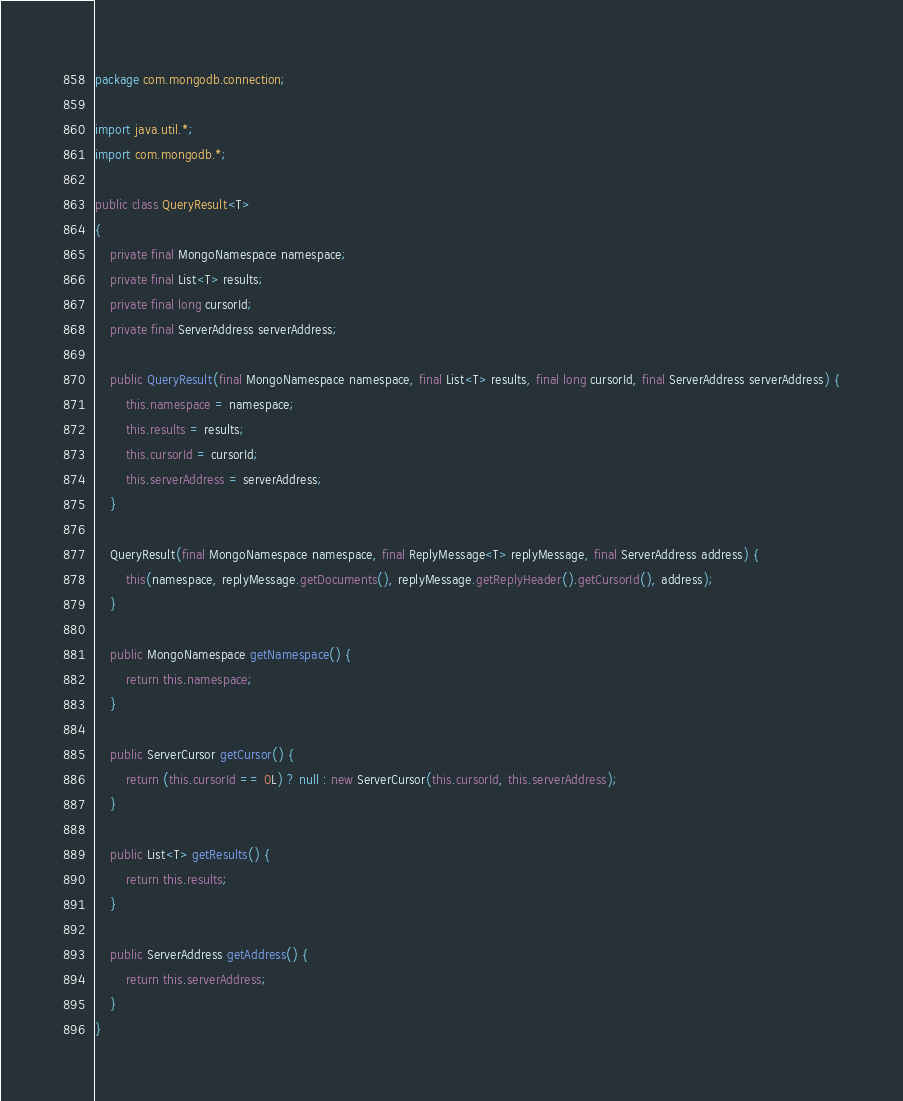Convert code to text. <code><loc_0><loc_0><loc_500><loc_500><_Java_>package com.mongodb.connection;

import java.util.*;
import com.mongodb.*;

public class QueryResult<T>
{
    private final MongoNamespace namespace;
    private final List<T> results;
    private final long cursorId;
    private final ServerAddress serverAddress;
    
    public QueryResult(final MongoNamespace namespace, final List<T> results, final long cursorId, final ServerAddress serverAddress) {
        this.namespace = namespace;
        this.results = results;
        this.cursorId = cursorId;
        this.serverAddress = serverAddress;
    }
    
    QueryResult(final MongoNamespace namespace, final ReplyMessage<T> replyMessage, final ServerAddress address) {
        this(namespace, replyMessage.getDocuments(), replyMessage.getReplyHeader().getCursorId(), address);
    }
    
    public MongoNamespace getNamespace() {
        return this.namespace;
    }
    
    public ServerCursor getCursor() {
        return (this.cursorId == 0L) ? null : new ServerCursor(this.cursorId, this.serverAddress);
    }
    
    public List<T> getResults() {
        return this.results;
    }
    
    public ServerAddress getAddress() {
        return this.serverAddress;
    }
}
</code> 